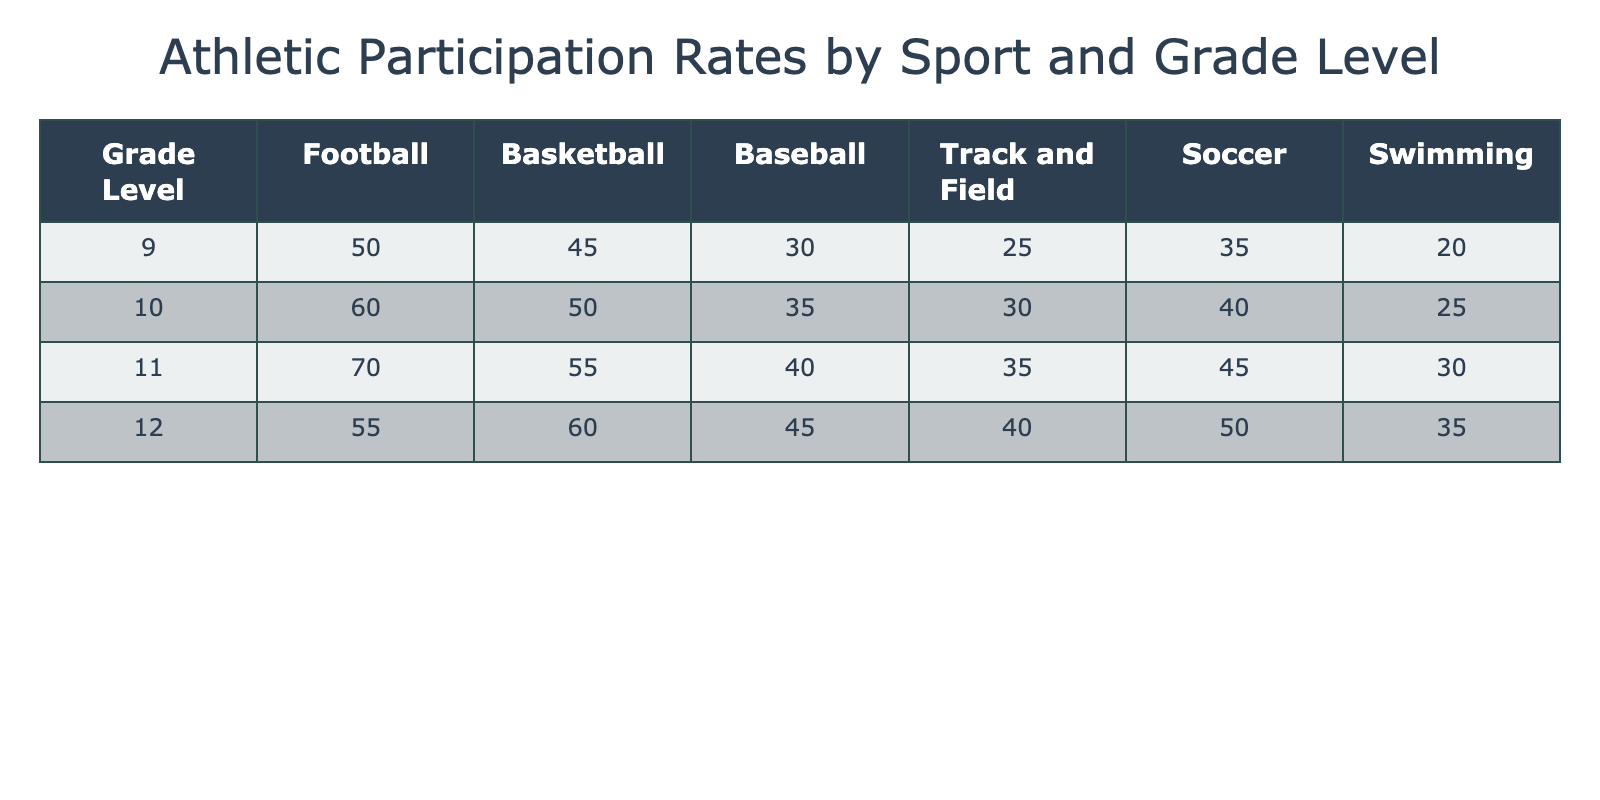What is the participation rate for Football among 11th graders? According to the table, the participation rate for Football for 11th graders is found in the corresponding row and column, which shows 70.
Answer: 70 Which sport had the highest participation rate in the 10th grade? By examining the 10th-grade row, we see that Football (60) has the highest rate compared to other sports: Basketball (50), Baseball (35), Track and Field (30), Soccer (40), and Swimming (25).
Answer: Football What is the average participation rate for Soccer across all grade levels? To find the average for Soccer, sum the participation rates: 35 (9th) + 40 (10th) + 45 (11th) + 50 (12th) = 170. Then divide by 4 (the number of grades): 170/4 = 42.5.
Answer: 42.5 Is the participation rate for Basketball higher among 12th graders than for 9th graders? The participation rate for Basketball among 12th graders is 60, while 9th graders have a rate of 45. Since 60 is greater than 45, the answer is yes.
Answer: Yes Which grade level had a total participation rate of 185 or more when the participation rates of Baseball and Swimming are added together? We need to check the combined rates of Baseball and Swimming for each grade: 
- 9th: 30 + 20 = 50
- 10th: 35 + 25 = 60
- 11th: 40 + 30 = 70
- 12th: 45 + 35 = 80
None of these totals are 185 or more, so there are no grade levels meeting this criterion.
Answer: No What is the difference in participation rates between Football and Track and Field for 12th graders? The participation rate for Football is 55, and for Track and Field it is 40. To find the difference, subtract Track and Field from Football: 55 - 40 = 15.
Answer: 15 What is the total participation rate for all sports in the 11th grade? To find the total participation rate for 11th graders, we sum all participation values for that grade: 70 (Football) + 55 (Basketball) + 40 (Baseball) + 35 (Track and Field) + 45 (Soccer) + 30 (Swimming) = 275.
Answer: 275 Is there any grade level where Swimming had higher participation than Track and Field? Looking at the data for Swimming and Track and Field:
- 9th: Swimming (20) vs Track (25) - No
- 10th: Swimming (25) vs Track (30) - No
- 11th: Swimming (30) vs Track (35) - No
- 12th: Swimming (35) vs Track (40) - No
In all instances, Swimming is lower than Track and Field.
Answer: No 